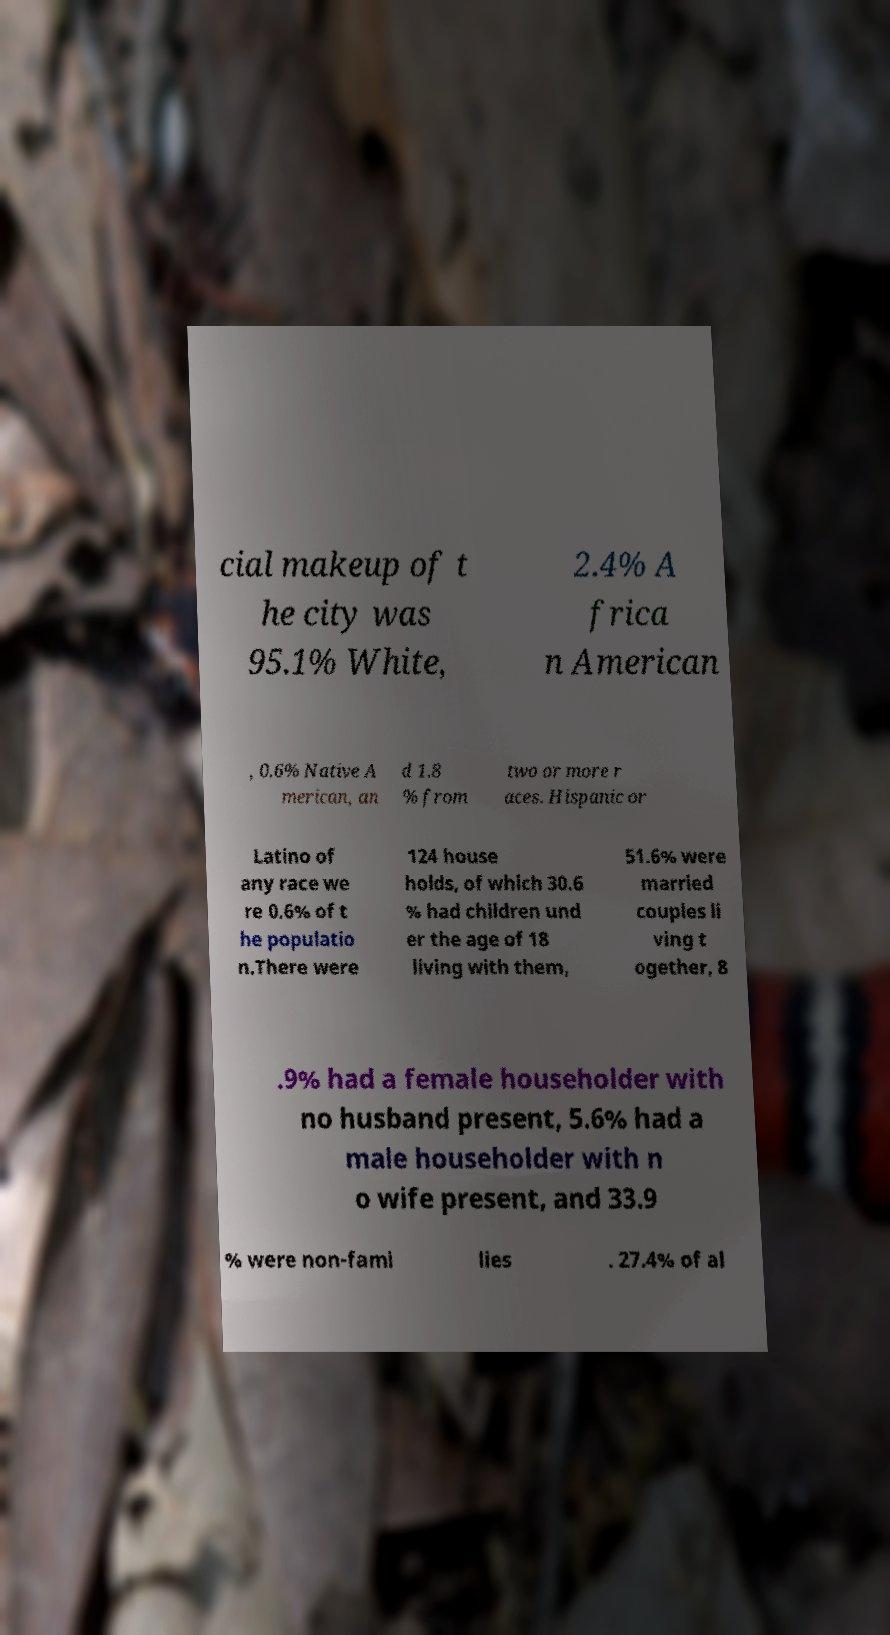Please identify and transcribe the text found in this image. cial makeup of t he city was 95.1% White, 2.4% A frica n American , 0.6% Native A merican, an d 1.8 % from two or more r aces. Hispanic or Latino of any race we re 0.6% of t he populatio n.There were 124 house holds, of which 30.6 % had children und er the age of 18 living with them, 51.6% were married couples li ving t ogether, 8 .9% had a female householder with no husband present, 5.6% had a male householder with n o wife present, and 33.9 % were non-fami lies . 27.4% of al 